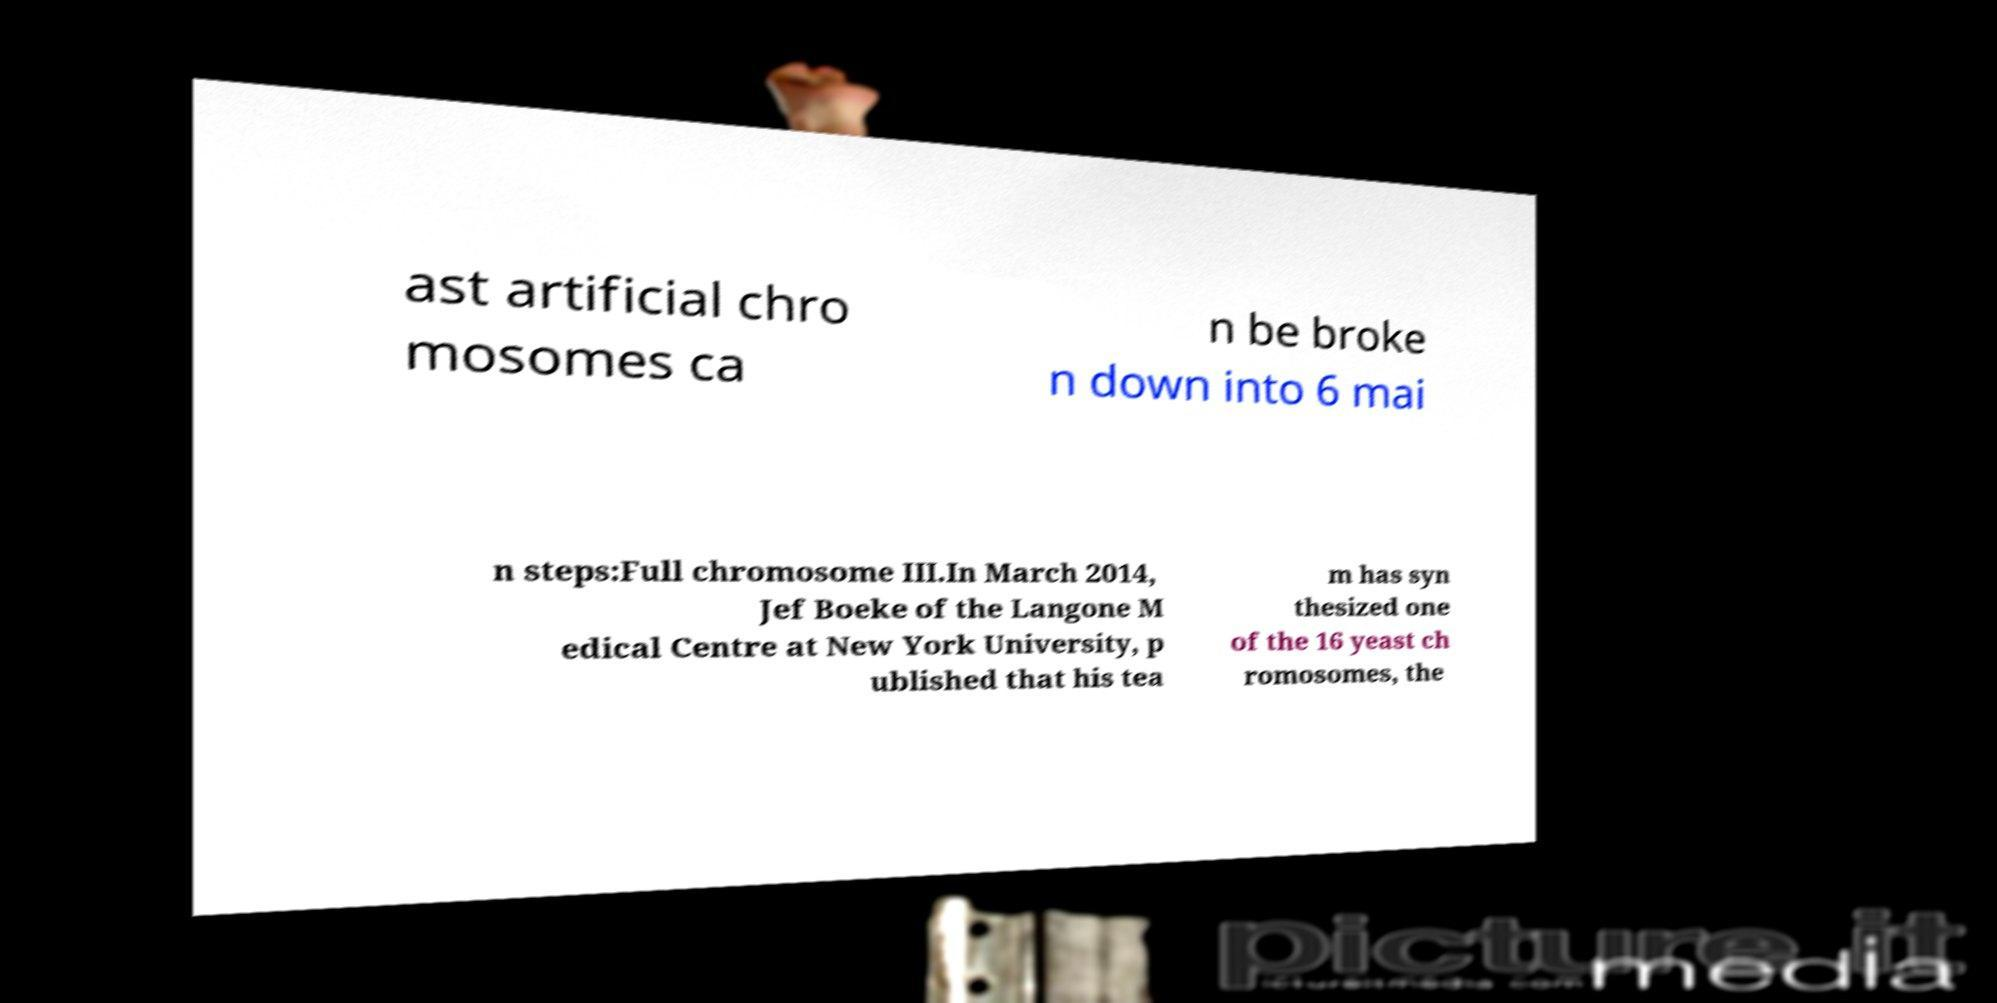Could you assist in decoding the text presented in this image and type it out clearly? ast artificial chro mosomes ca n be broke n down into 6 mai n steps:Full chromosome III.In March 2014, Jef Boeke of the Langone M edical Centre at New York University, p ublished that his tea m has syn thesized one of the 16 yeast ch romosomes, the 